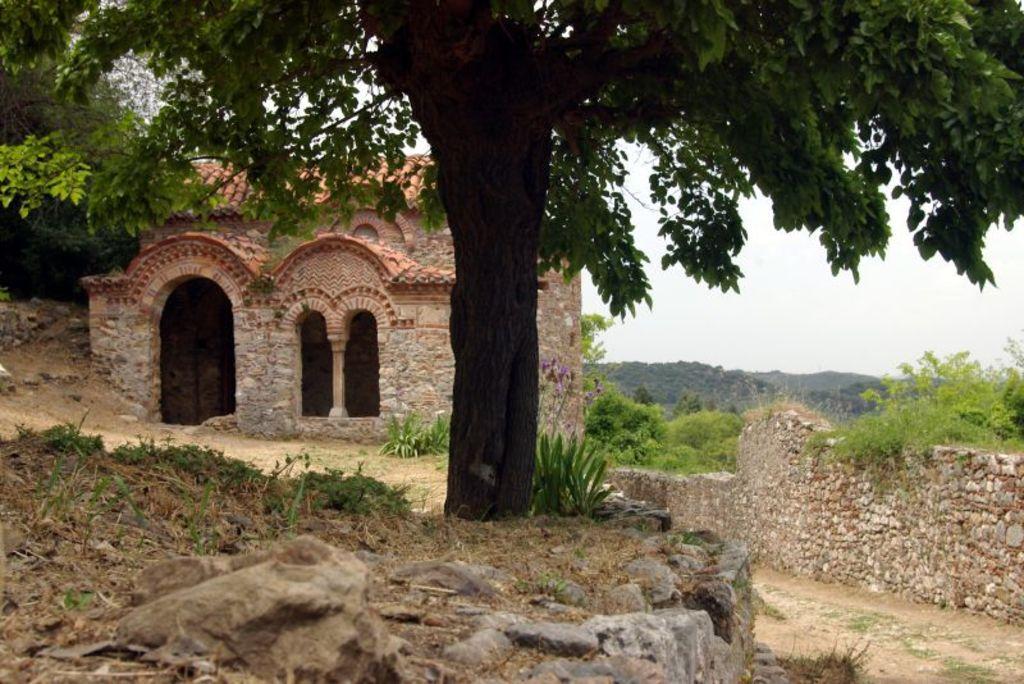How would you summarize this image in a sentence or two? In the foreground of this image, there is the rock, grass, tree and a plant. In the background, there is a stone wall, trees, a building, and an arch to it and the sky. 